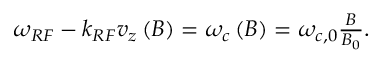Convert formula to latex. <formula><loc_0><loc_0><loc_500><loc_500>\begin{array} { r } { \omega _ { R F } - k _ { R F } v _ { z } \left ( B \right ) = \omega _ { c } \left ( B \right ) = \omega _ { c , 0 } \frac { B } { B _ { 0 } } . } \end{array}</formula> 